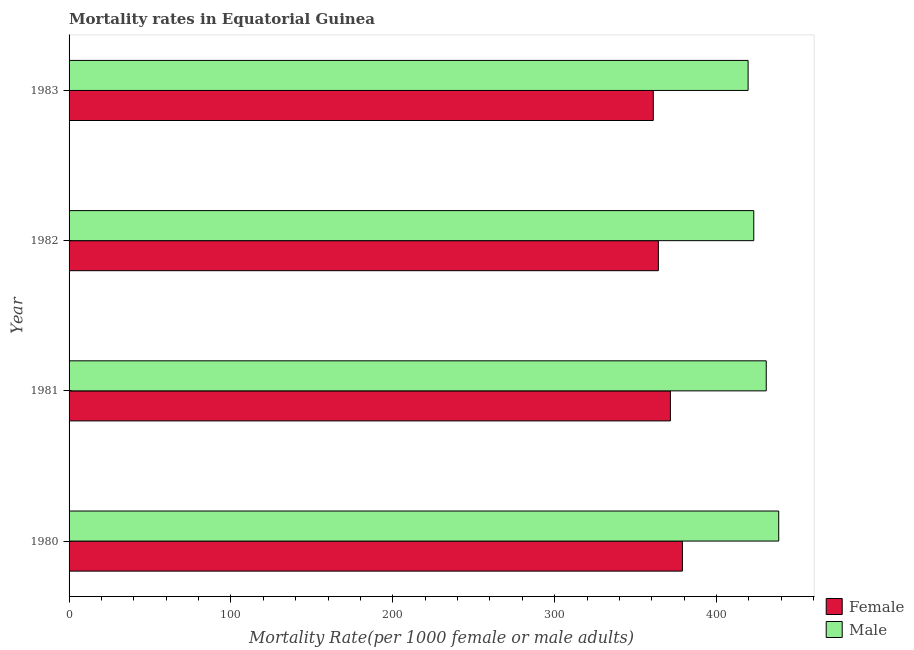How many different coloured bars are there?
Offer a terse response. 2. What is the label of the 2nd group of bars from the top?
Ensure brevity in your answer.  1982. What is the female mortality rate in 1983?
Ensure brevity in your answer.  360.94. Across all years, what is the maximum male mortality rate?
Make the answer very short. 438.44. Across all years, what is the minimum female mortality rate?
Keep it short and to the point. 360.94. What is the total female mortality rate in the graph?
Provide a succinct answer. 1475.48. What is the difference between the female mortality rate in 1981 and that in 1983?
Give a very brief answer. 10.57. What is the difference between the female mortality rate in 1980 and the male mortality rate in 1982?
Offer a very short reply. -44.1. What is the average female mortality rate per year?
Provide a short and direct response. 368.87. In the year 1983, what is the difference between the female mortality rate and male mortality rate?
Provide a short and direct response. -58.59. In how many years, is the female mortality rate greater than 240 ?
Ensure brevity in your answer.  4. What is the ratio of the male mortality rate in 1980 to that in 1983?
Offer a terse response. 1.04. Is the female mortality rate in 1980 less than that in 1981?
Your answer should be compact. No. What is the difference between the highest and the second highest female mortality rate?
Keep it short and to the point. 7.42. What is the difference between the highest and the lowest female mortality rate?
Your answer should be very brief. 17.99. In how many years, is the male mortality rate greater than the average male mortality rate taken over all years?
Ensure brevity in your answer.  2. How many bars are there?
Offer a very short reply. 8. Are all the bars in the graph horizontal?
Your response must be concise. Yes. How many years are there in the graph?
Give a very brief answer. 4. Does the graph contain any zero values?
Your response must be concise. No. Does the graph contain grids?
Provide a succinct answer. No. Where does the legend appear in the graph?
Your answer should be compact. Bottom right. How many legend labels are there?
Your answer should be compact. 2. How are the legend labels stacked?
Your answer should be very brief. Vertical. What is the title of the graph?
Offer a very short reply. Mortality rates in Equatorial Guinea. Does "UN agencies" appear as one of the legend labels in the graph?
Provide a succinct answer. No. What is the label or title of the X-axis?
Provide a short and direct response. Mortality Rate(per 1000 female or male adults). What is the Mortality Rate(per 1000 female or male adults) of Female in 1980?
Make the answer very short. 378.93. What is the Mortality Rate(per 1000 female or male adults) in Male in 1980?
Offer a very short reply. 438.44. What is the Mortality Rate(per 1000 female or male adults) in Female in 1981?
Give a very brief answer. 371.51. What is the Mortality Rate(per 1000 female or male adults) of Male in 1981?
Ensure brevity in your answer.  430.74. What is the Mortality Rate(per 1000 female or male adults) of Female in 1982?
Offer a very short reply. 364.09. What is the Mortality Rate(per 1000 female or male adults) in Male in 1982?
Give a very brief answer. 423.04. What is the Mortality Rate(per 1000 female or male adults) of Female in 1983?
Provide a succinct answer. 360.94. What is the Mortality Rate(per 1000 female or male adults) in Male in 1983?
Your answer should be compact. 419.53. Across all years, what is the maximum Mortality Rate(per 1000 female or male adults) in Female?
Your response must be concise. 378.93. Across all years, what is the maximum Mortality Rate(per 1000 female or male adults) in Male?
Offer a terse response. 438.44. Across all years, what is the minimum Mortality Rate(per 1000 female or male adults) of Female?
Offer a very short reply. 360.94. Across all years, what is the minimum Mortality Rate(per 1000 female or male adults) of Male?
Give a very brief answer. 419.53. What is the total Mortality Rate(per 1000 female or male adults) of Female in the graph?
Provide a short and direct response. 1475.48. What is the total Mortality Rate(per 1000 female or male adults) of Male in the graph?
Provide a succinct answer. 1711.73. What is the difference between the Mortality Rate(per 1000 female or male adults) in Female in 1980 and that in 1981?
Provide a succinct answer. 7.42. What is the difference between the Mortality Rate(per 1000 female or male adults) of Male in 1980 and that in 1981?
Provide a succinct answer. 7.7. What is the difference between the Mortality Rate(per 1000 female or male adults) in Female in 1980 and that in 1982?
Give a very brief answer. 14.84. What is the difference between the Mortality Rate(per 1000 female or male adults) of Female in 1980 and that in 1983?
Provide a short and direct response. 17.99. What is the difference between the Mortality Rate(per 1000 female or male adults) in Male in 1980 and that in 1983?
Offer a very short reply. 18.91. What is the difference between the Mortality Rate(per 1000 female or male adults) of Female in 1981 and that in 1982?
Provide a short and direct response. 7.42. What is the difference between the Mortality Rate(per 1000 female or male adults) in Male in 1981 and that in 1982?
Your answer should be compact. 7.7. What is the difference between the Mortality Rate(per 1000 female or male adults) of Female in 1981 and that in 1983?
Provide a succinct answer. 10.57. What is the difference between the Mortality Rate(per 1000 female or male adults) of Male in 1981 and that in 1983?
Ensure brevity in your answer.  11.21. What is the difference between the Mortality Rate(per 1000 female or male adults) in Female in 1982 and that in 1983?
Keep it short and to the point. 3.15. What is the difference between the Mortality Rate(per 1000 female or male adults) in Male in 1982 and that in 1983?
Ensure brevity in your answer.  3.51. What is the difference between the Mortality Rate(per 1000 female or male adults) in Female in 1980 and the Mortality Rate(per 1000 female or male adults) in Male in 1981?
Give a very brief answer. -51.8. What is the difference between the Mortality Rate(per 1000 female or male adults) of Female in 1980 and the Mortality Rate(per 1000 female or male adults) of Male in 1982?
Offer a terse response. -44.1. What is the difference between the Mortality Rate(per 1000 female or male adults) in Female in 1980 and the Mortality Rate(per 1000 female or male adults) in Male in 1983?
Make the answer very short. -40.59. What is the difference between the Mortality Rate(per 1000 female or male adults) of Female in 1981 and the Mortality Rate(per 1000 female or male adults) of Male in 1982?
Your answer should be very brief. -51.52. What is the difference between the Mortality Rate(per 1000 female or male adults) in Female in 1981 and the Mortality Rate(per 1000 female or male adults) in Male in 1983?
Offer a terse response. -48.02. What is the difference between the Mortality Rate(per 1000 female or male adults) in Female in 1982 and the Mortality Rate(per 1000 female or male adults) in Male in 1983?
Ensure brevity in your answer.  -55.44. What is the average Mortality Rate(per 1000 female or male adults) of Female per year?
Provide a succinct answer. 368.87. What is the average Mortality Rate(per 1000 female or male adults) in Male per year?
Your answer should be compact. 427.93. In the year 1980, what is the difference between the Mortality Rate(per 1000 female or male adults) of Female and Mortality Rate(per 1000 female or male adults) of Male?
Your answer should be very brief. -59.5. In the year 1981, what is the difference between the Mortality Rate(per 1000 female or male adults) in Female and Mortality Rate(per 1000 female or male adults) in Male?
Ensure brevity in your answer.  -59.22. In the year 1982, what is the difference between the Mortality Rate(per 1000 female or male adults) of Female and Mortality Rate(per 1000 female or male adults) of Male?
Provide a succinct answer. -58.95. In the year 1983, what is the difference between the Mortality Rate(per 1000 female or male adults) in Female and Mortality Rate(per 1000 female or male adults) in Male?
Make the answer very short. -58.59. What is the ratio of the Mortality Rate(per 1000 female or male adults) in Female in 1980 to that in 1981?
Provide a short and direct response. 1.02. What is the ratio of the Mortality Rate(per 1000 female or male adults) of Male in 1980 to that in 1981?
Provide a succinct answer. 1.02. What is the ratio of the Mortality Rate(per 1000 female or male adults) in Female in 1980 to that in 1982?
Offer a very short reply. 1.04. What is the ratio of the Mortality Rate(per 1000 female or male adults) of Male in 1980 to that in 1982?
Make the answer very short. 1.04. What is the ratio of the Mortality Rate(per 1000 female or male adults) of Female in 1980 to that in 1983?
Your answer should be compact. 1.05. What is the ratio of the Mortality Rate(per 1000 female or male adults) in Male in 1980 to that in 1983?
Give a very brief answer. 1.05. What is the ratio of the Mortality Rate(per 1000 female or male adults) of Female in 1981 to that in 1982?
Provide a succinct answer. 1.02. What is the ratio of the Mortality Rate(per 1000 female or male adults) of Male in 1981 to that in 1982?
Make the answer very short. 1.02. What is the ratio of the Mortality Rate(per 1000 female or male adults) in Female in 1981 to that in 1983?
Your answer should be very brief. 1.03. What is the ratio of the Mortality Rate(per 1000 female or male adults) in Male in 1981 to that in 1983?
Keep it short and to the point. 1.03. What is the ratio of the Mortality Rate(per 1000 female or male adults) in Female in 1982 to that in 1983?
Your response must be concise. 1.01. What is the ratio of the Mortality Rate(per 1000 female or male adults) of Male in 1982 to that in 1983?
Your answer should be compact. 1.01. What is the difference between the highest and the second highest Mortality Rate(per 1000 female or male adults) in Female?
Offer a very short reply. 7.42. What is the difference between the highest and the lowest Mortality Rate(per 1000 female or male adults) in Female?
Keep it short and to the point. 17.99. What is the difference between the highest and the lowest Mortality Rate(per 1000 female or male adults) in Male?
Your response must be concise. 18.91. 